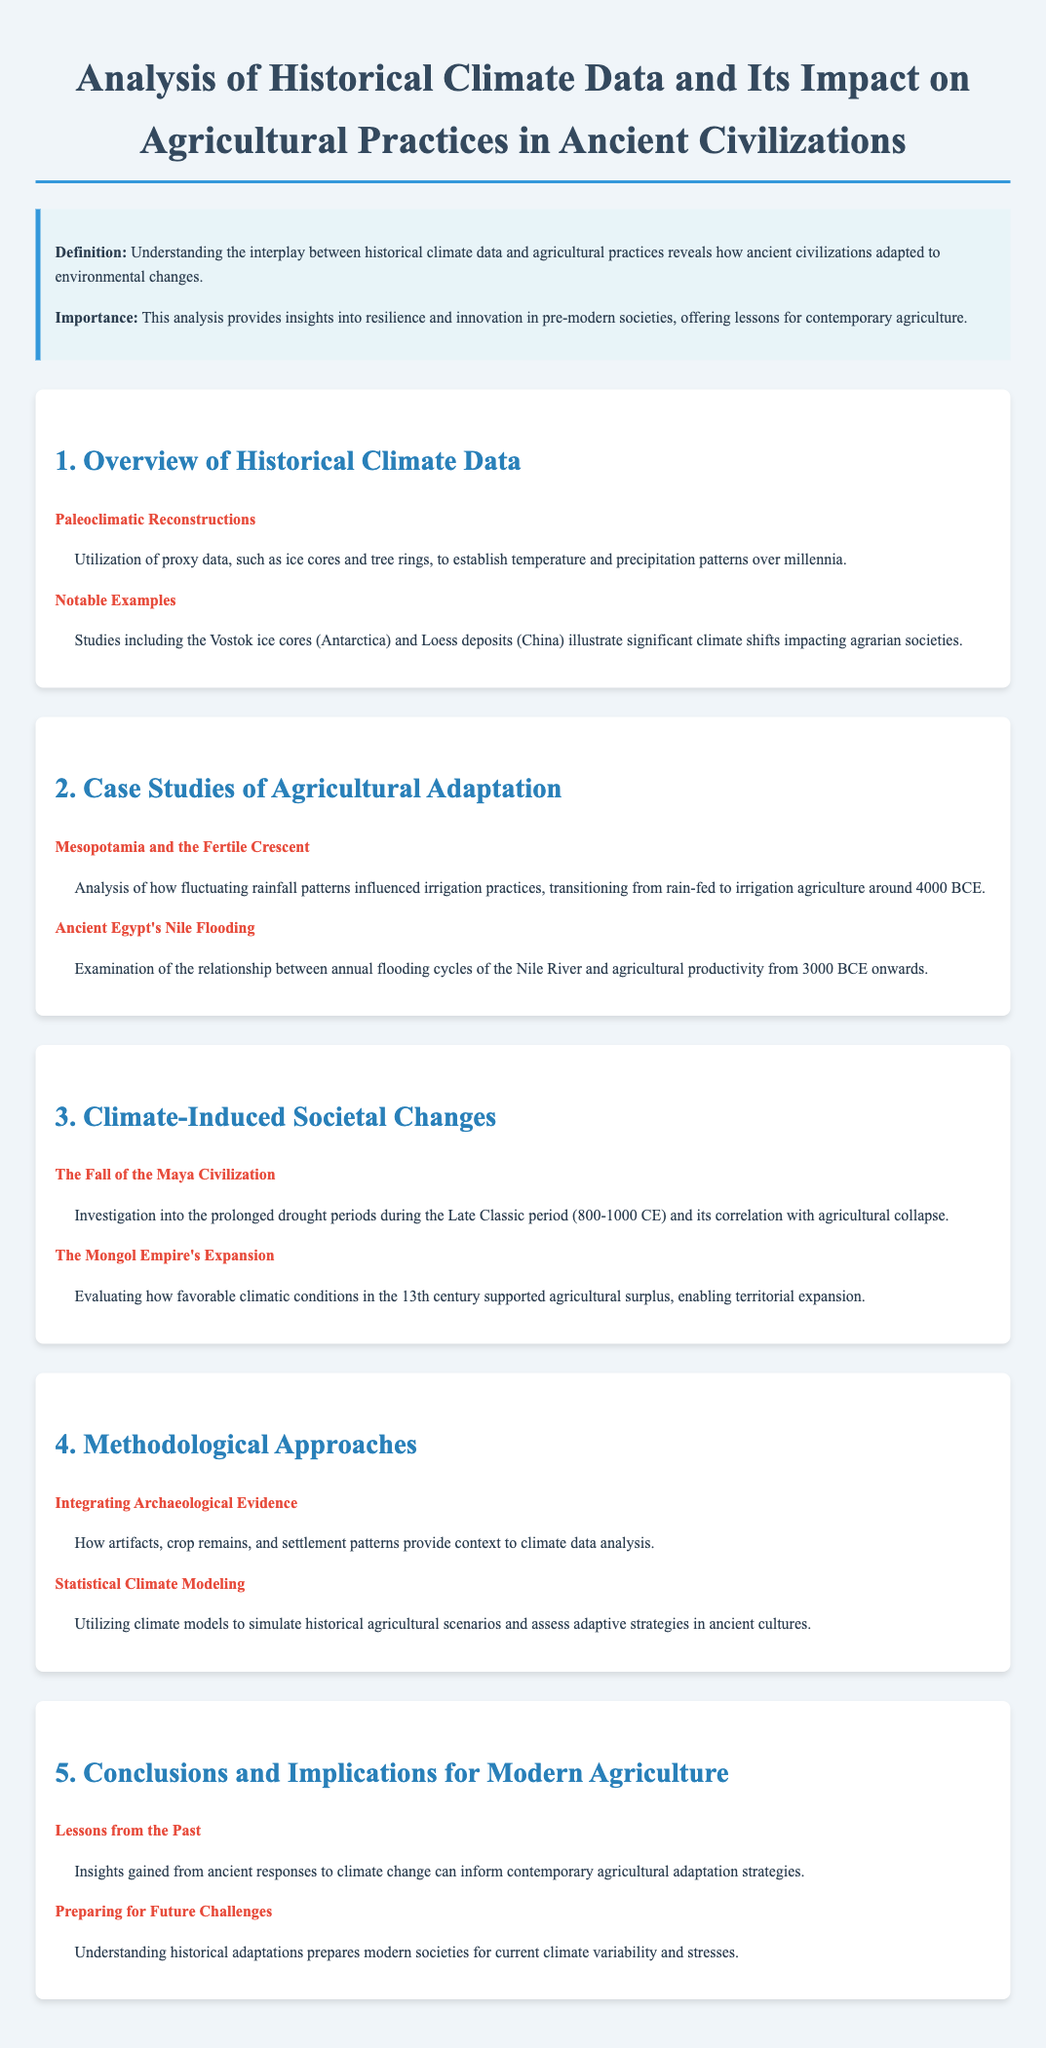What is the focus of the document? The document discusses the relationship between historical climate data and agricultural practices in ancient civilizations.
Answer: Historical climate data and agricultural practices in ancient civilizations What two techniques are used for paleoclimatic reconstructions? The document mentions the use of proxy data, notably ice cores and tree rings, for climate pattern establishment.
Answer: Ice cores and tree rings What significant pattern transition occurred in Mesopotamia around 4000 BCE? The document states that irrigation agriculture became more prominent due to fluctuating rainfall patterns.
Answer: Transitioning from rain-fed to irrigation agriculture Which river's flooding is linked to agricultural productivity in Ancient Egypt? The document explicitly identifies the Nile river as the key factor affecting agriculture.
Answer: Nile River During which period did the Maya Civilization experience prolonged droughts? The document specifies the Late Classic period as the time of severe drought impacts on the civilization.
Answer: Late Classic period (800-1000 CE) What contributed to the Mongol Empire's territorial expansion in the 13th century? The document attributes the favorable climatic conditions and agricultural surplus to the expansion of the Mongol Empire.
Answer: Favorable climatic conditions and agricultural surplus What role do archaeological artifacts play in climate data analysis? The document describes artifacts as providing context to enhance the understanding of climate data.
Answer: Context to climate data analysis What are two implications for modern agriculture suggested by the document? The document notes that insights from ancient adaptations inform contemporary strategies and prepare for future climate challenges.
Answer: Inform contemporary agricultural adaptation strategies and prepare for future challenges 